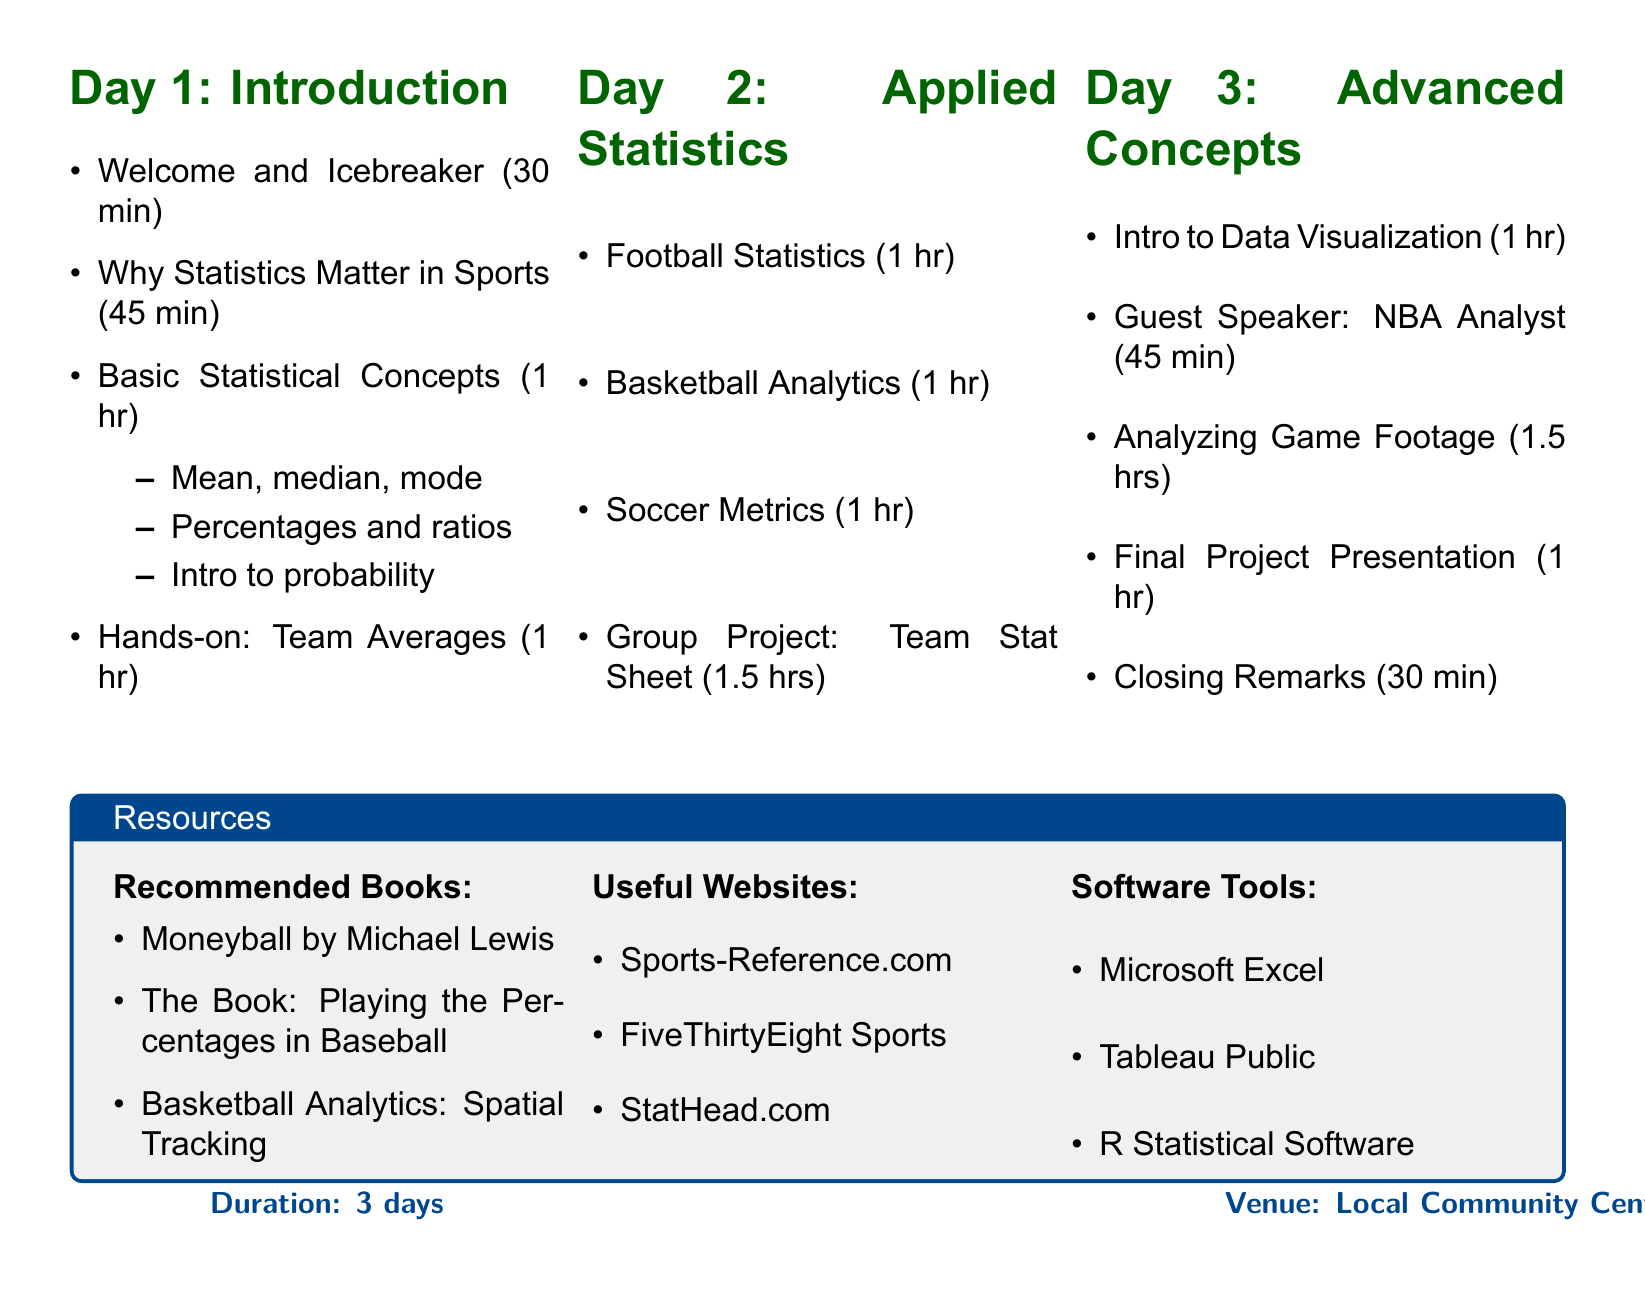What is the title of the clinic? The title of the clinic is mentioned at the beginning of the document.
Answer: Youth Sports Statistics Clinic: Empowering Young Athletes with Data How long is the clinic scheduled for? The duration of the clinic is stated in the overview section of the document.
Answer: 3 days Who is the target audience for this clinic? The target audience is specified in the overview section.
Answer: Athletes aged 12-18 What is the theme for Day 1? The theme for Day 1 can be found in the section detailing the first day's agenda.
Answer: Introduction to Sports Statistics Which statistical concept is introduced on Day 1? Basic Statistical Concepts that are taught on Day 1 are listed in the respective session's description.
Answer: Mean, median, and mode How long is the guest speaker session on Day 3? The duration of the guest speaker session is specified in the Day 3 schedule.
Answer: 45 minutes What project do participants work on during Day 2? The group project is outlined in the agenda for Day 2.
Answer: Creating a Team Stat Sheet Name one recommended book. The recommended books are listed in the resources section.
Answer: Moneyball by Michael Lewis Which software tool is listed for data visualization? The software tools that can be useful for participants are outlined in the resources section.
Answer: Microsoft Excel What is discussed during the closing remarks? The content of the closing remarks is provided in the Day 3 section.
Answer: Discussion on how to apply learned skills in local sports clubs 